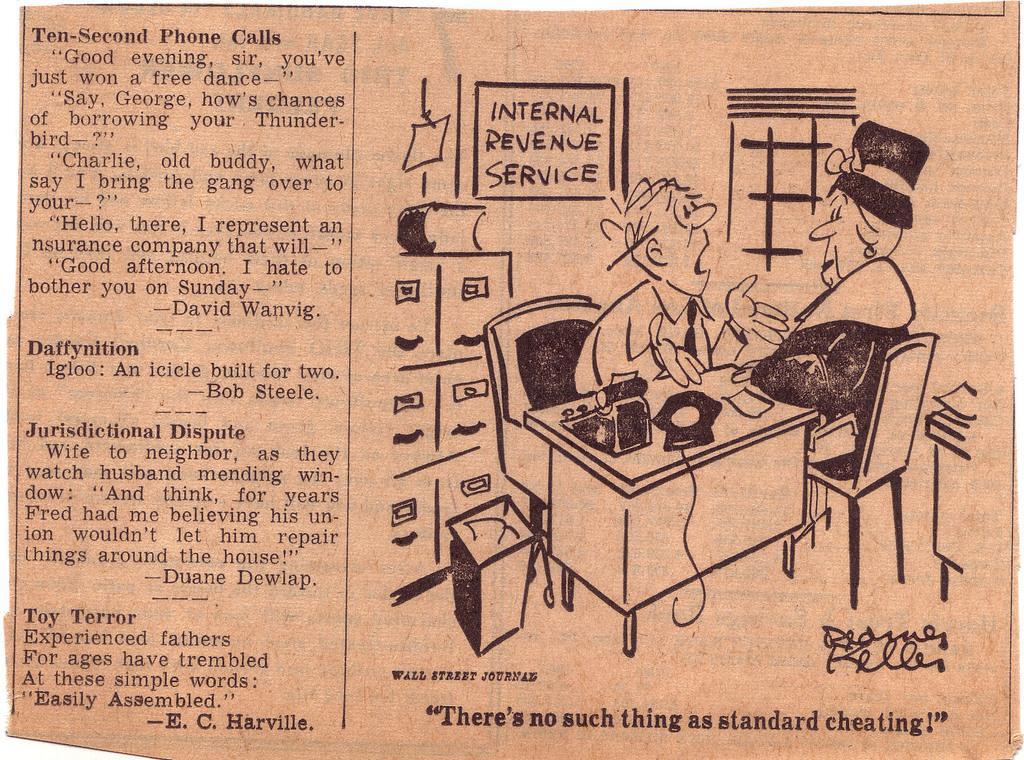In one or two sentences, can you explain what this image depicts? This is the picture of a newspaper. On the paper there is text and there is a sketch of two people sitting and talking and there are objects on the table and there is a book on the cupboard and there is a dustbin. At the back there is a window and there is text on the board. At the bottom there is text. 